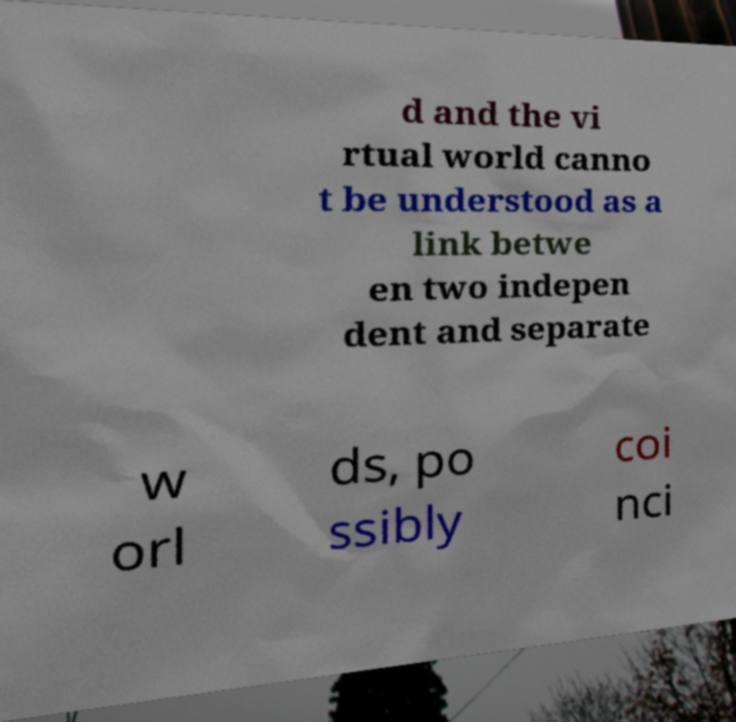I need the written content from this picture converted into text. Can you do that? d and the vi rtual world canno t be understood as a link betwe en two indepen dent and separate w orl ds, po ssibly coi nci 